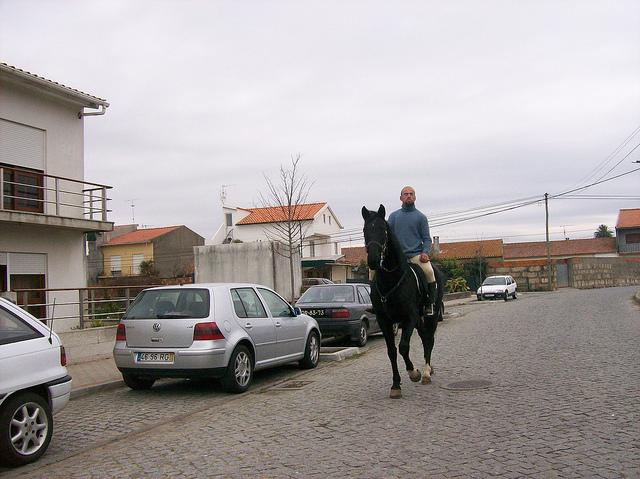What is he doing with the horse? Please explain your reasoning. riding it. The man is mounted on the horse. 